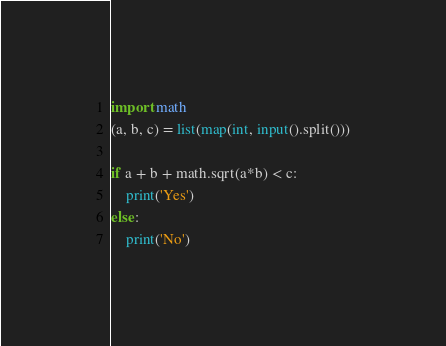<code> <loc_0><loc_0><loc_500><loc_500><_Python_>import math
(a, b, c) = list(map(int, input().split()))

if a + b + math.sqrt(a*b) < c:
    print('Yes')
else:
    print('No')
</code> 